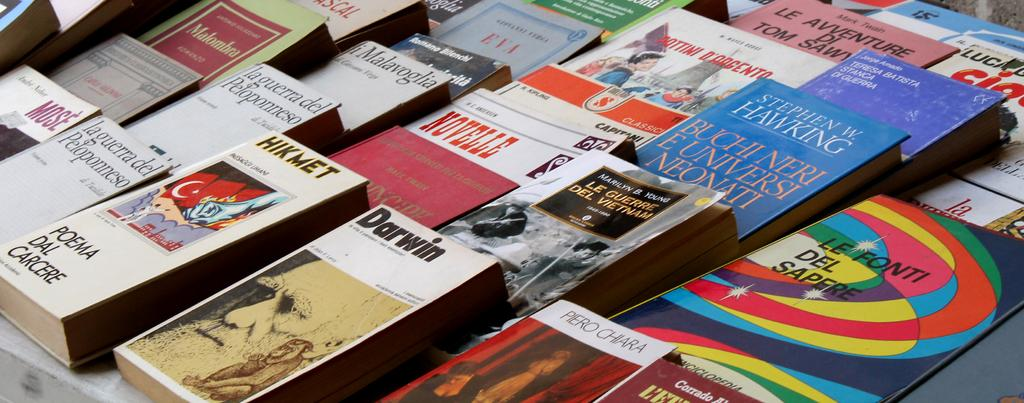<image>
Write a terse but informative summary of the picture. Stephen W. Hawking has one of the books he wrote shown here in a different language. 